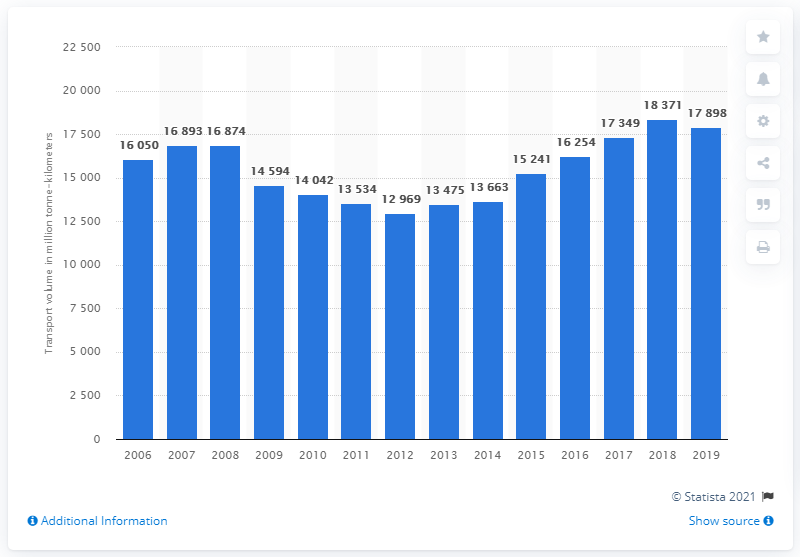Give some essential details in this illustration. In 2019, a total of 17,898 metric tons of freight was transported in Croatia. 